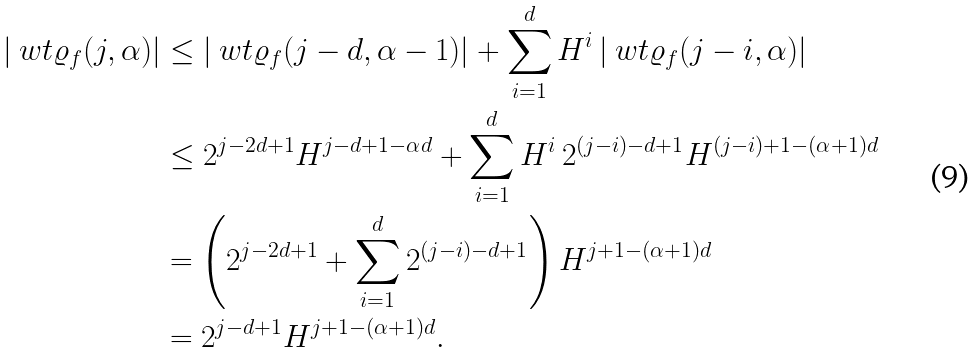Convert formula to latex. <formula><loc_0><loc_0><loc_500><loc_500>| \ w t \varrho _ { f } ( j , \alpha ) | & \leq | \ w t \varrho _ { f } ( j - d , \alpha - 1 ) | + \sum _ { i = 1 } ^ { d } H ^ { i } \, | \ w t \varrho _ { f } ( j - i , \alpha ) | \\ & \leq 2 ^ { j - 2 d + 1 } H ^ { j - d + 1 - \alpha d } + \sum _ { i = 1 } ^ { d } H ^ { i } \, 2 ^ { ( j - i ) - d + 1 } H ^ { ( j - i ) + 1 - ( \alpha + 1 ) d } \\ & = \left ( 2 ^ { j - 2 d + 1 } + \sum _ { i = 1 } ^ { d } 2 ^ { ( j - i ) - d + 1 } \right ) H ^ { j + 1 - ( \alpha + 1 ) d } \\ & = 2 ^ { j - d + 1 } H ^ { j + 1 - ( \alpha + 1 ) d } .</formula> 